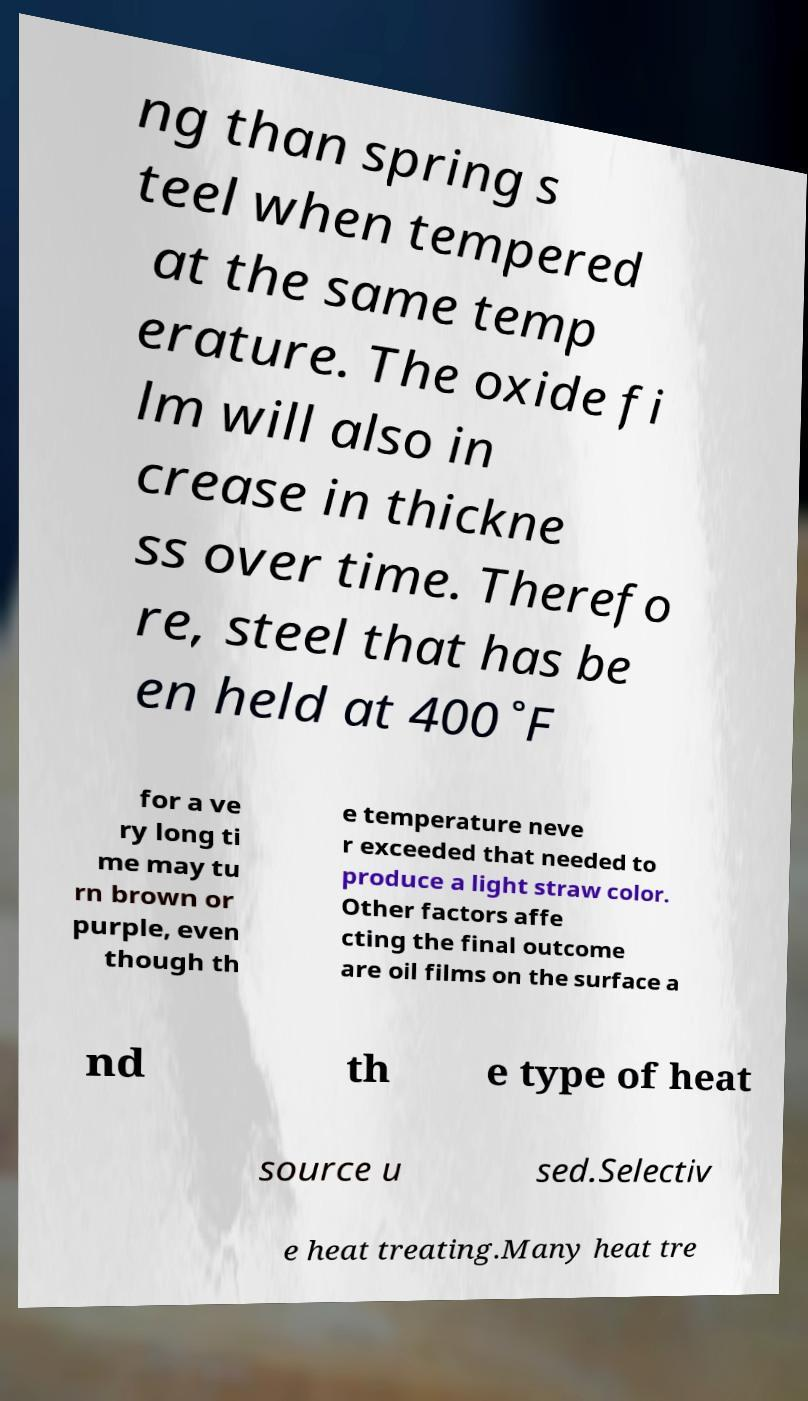I need the written content from this picture converted into text. Can you do that? ng than spring s teel when tempered at the same temp erature. The oxide fi lm will also in crease in thickne ss over time. Therefo re, steel that has be en held at 400˚F for a ve ry long ti me may tu rn brown or purple, even though th e temperature neve r exceeded that needed to produce a light straw color. Other factors affe cting the final outcome are oil films on the surface a nd th e type of heat source u sed.Selectiv e heat treating.Many heat tre 